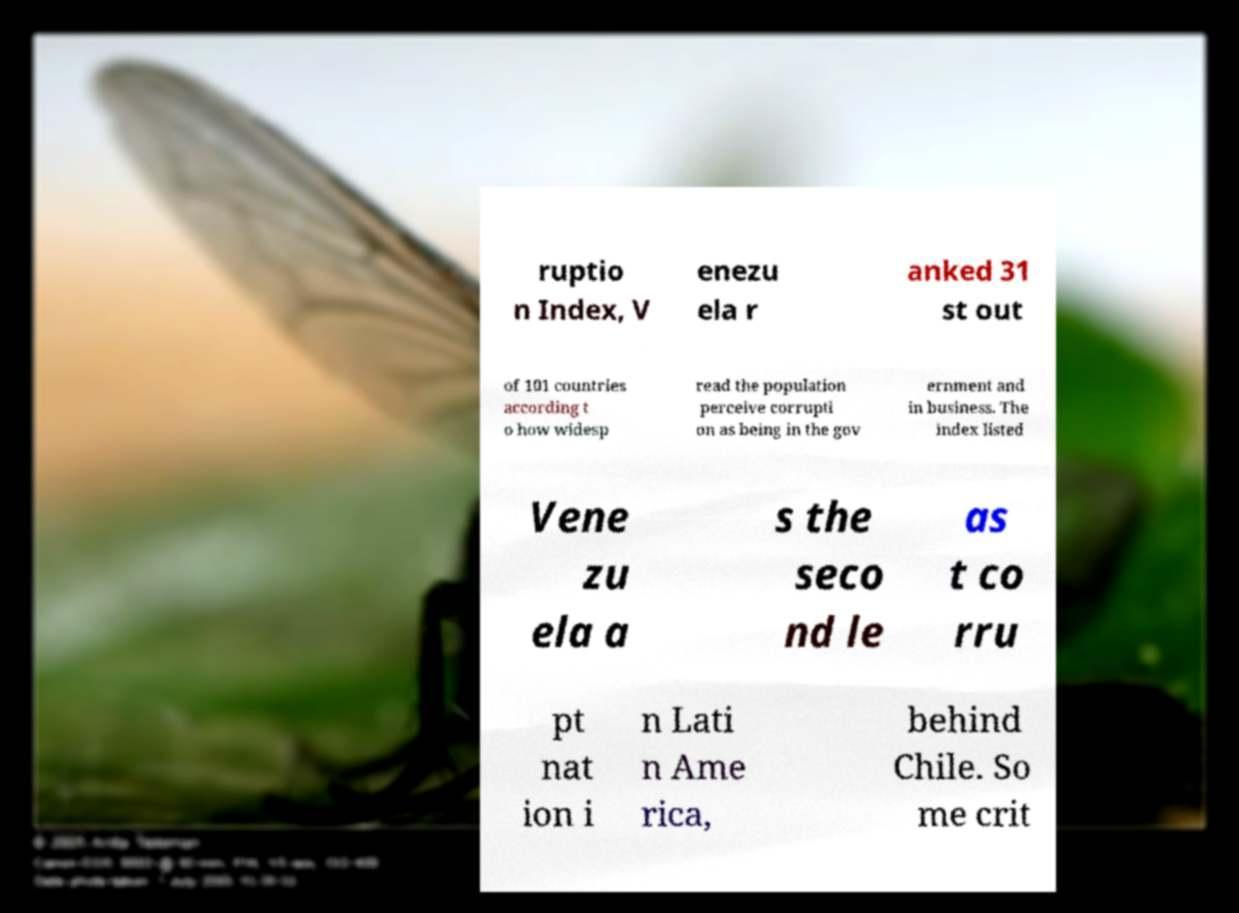Please read and relay the text visible in this image. What does it say? ruptio n Index, V enezu ela r anked 31 st out of 101 countries according t o how widesp read the population perceive corrupti on as being in the gov ernment and in business. The index listed Vene zu ela a s the seco nd le as t co rru pt nat ion i n Lati n Ame rica, behind Chile. So me crit 